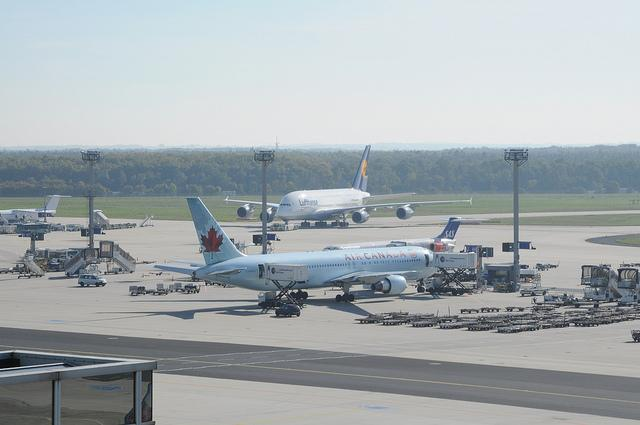What continent is the plane in the foreground from? Please explain your reasoning. north america. The country of origin is on the side of the plane. 